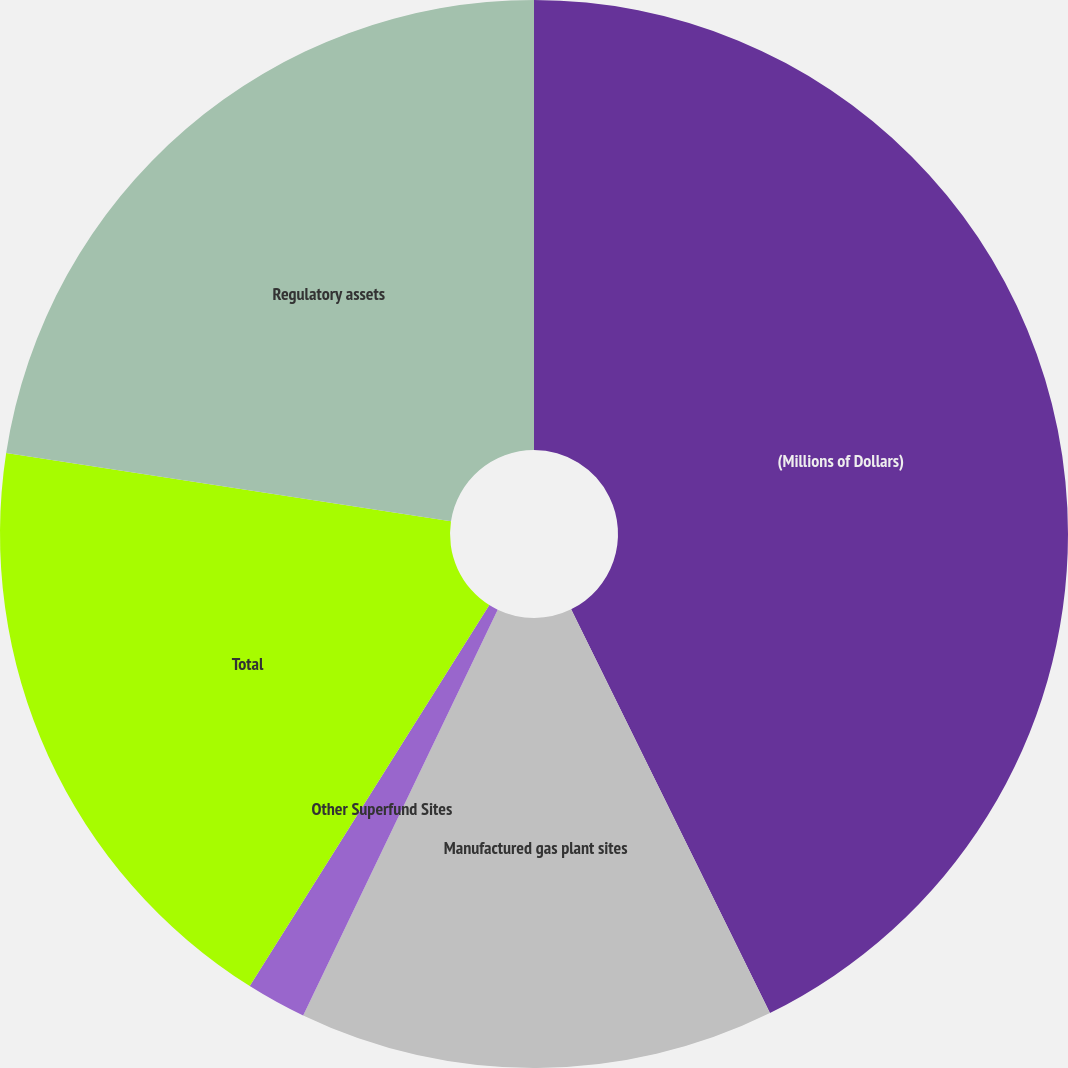<chart> <loc_0><loc_0><loc_500><loc_500><pie_chart><fcel>(Millions of Dollars)<fcel>Manufactured gas plant sites<fcel>Other Superfund Sites<fcel>Total<fcel>Regulatory assets<nl><fcel>42.72%<fcel>14.4%<fcel>1.82%<fcel>18.49%<fcel>22.58%<nl></chart> 